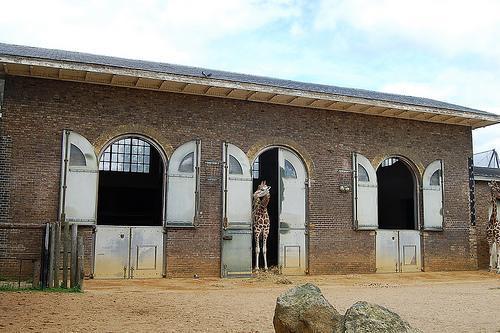How many giraffes are there?
Give a very brief answer. 1. 